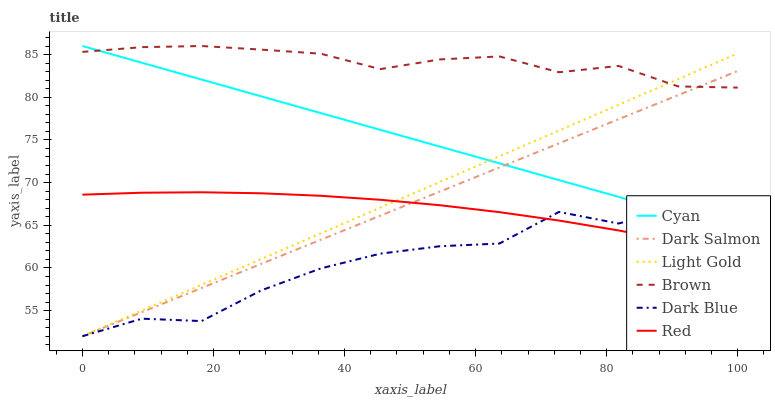Does Dark Blue have the minimum area under the curve?
Answer yes or no. Yes. Does Brown have the maximum area under the curve?
Answer yes or no. Yes. Does Dark Salmon have the minimum area under the curve?
Answer yes or no. No. Does Dark Salmon have the maximum area under the curve?
Answer yes or no. No. Is Dark Salmon the smoothest?
Answer yes or no. Yes. Is Dark Blue the roughest?
Answer yes or no. Yes. Is Dark Blue the smoothest?
Answer yes or no. No. Is Dark Salmon the roughest?
Answer yes or no. No. Does Dark Salmon have the lowest value?
Answer yes or no. Yes. Does Cyan have the lowest value?
Answer yes or no. No. Does Cyan have the highest value?
Answer yes or no. Yes. Does Dark Salmon have the highest value?
Answer yes or no. No. Is Dark Blue less than Brown?
Answer yes or no. Yes. Is Brown greater than Red?
Answer yes or no. Yes. Does Red intersect Dark Blue?
Answer yes or no. Yes. Is Red less than Dark Blue?
Answer yes or no. No. Is Red greater than Dark Blue?
Answer yes or no. No. Does Dark Blue intersect Brown?
Answer yes or no. No. 